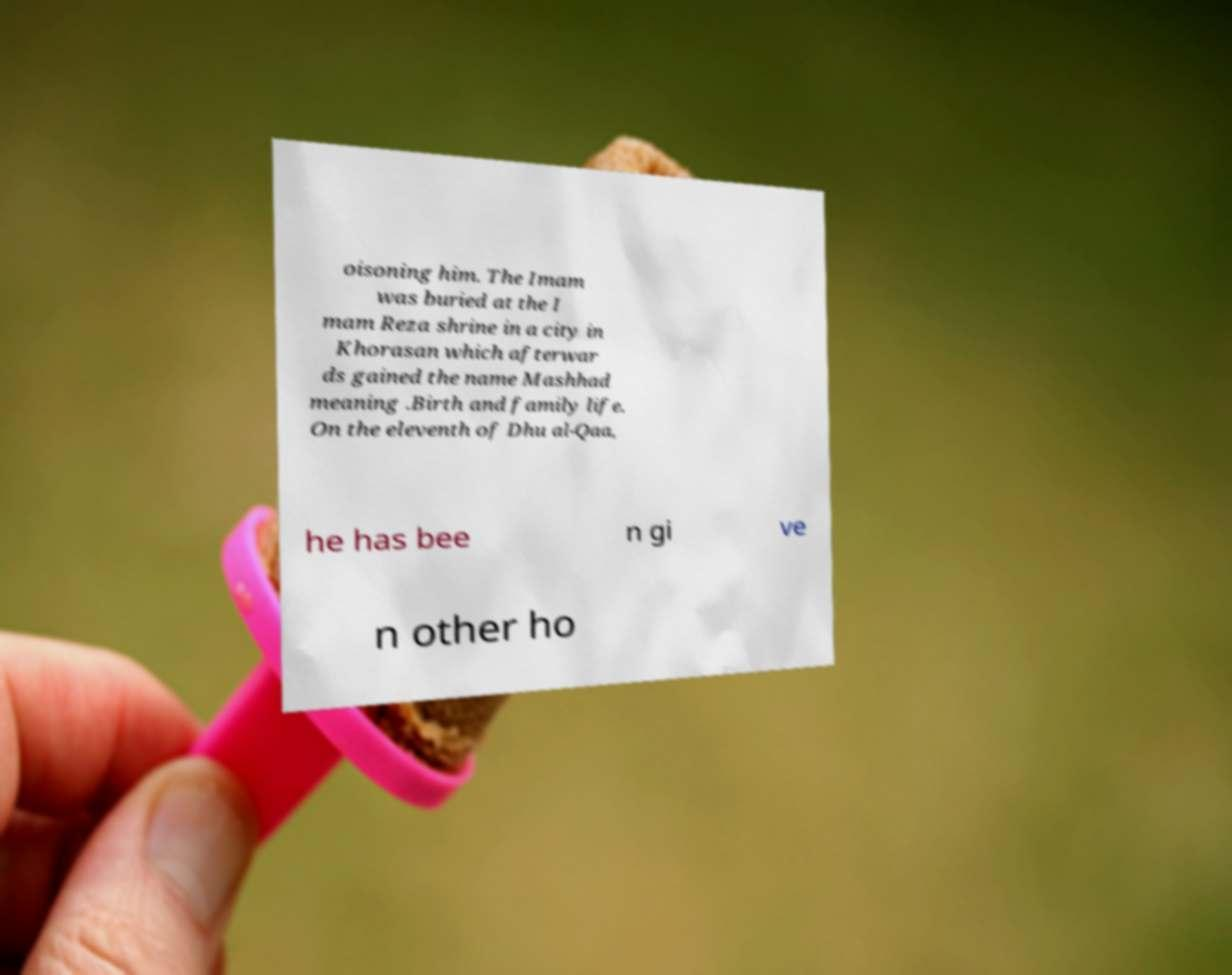For documentation purposes, I need the text within this image transcribed. Could you provide that? oisoning him. The Imam was buried at the I mam Reza shrine in a city in Khorasan which afterwar ds gained the name Mashhad meaning .Birth and family life. On the eleventh of Dhu al-Qaa, he has bee n gi ve n other ho 